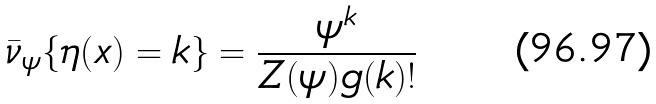Convert formula to latex. <formula><loc_0><loc_0><loc_500><loc_500>\bar { \nu } _ { \psi } \{ \eta ( x ) = k \} = \frac { \psi ^ { k } } { Z ( \psi ) g ( k ) ! }</formula> 